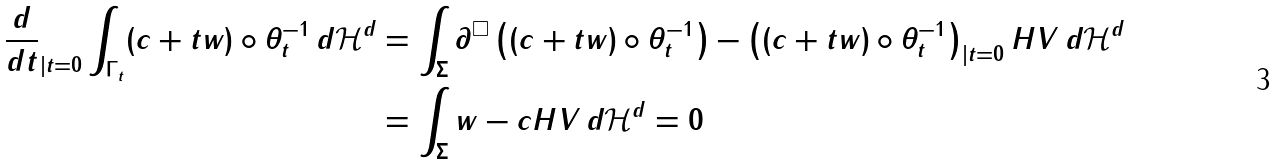<formula> <loc_0><loc_0><loc_500><loc_500>\frac { d } { d t } _ { | t = 0 } \int _ { \Gamma _ { t } } ( c + t w ) \circ \theta _ { t } ^ { - 1 } \, d \mathcal { H } ^ { d } & = \int _ { \Sigma } \partial ^ { \square } \left ( ( c + t w ) \circ \theta _ { t } ^ { - 1 } \right ) - \left ( ( c + t w ) \circ \theta _ { t } ^ { - 1 } \right ) _ { | t = 0 } H V \, d \mathcal { H } ^ { d } \\ & = \int _ { \Sigma } w - c H V \, d \mathcal { H } ^ { d } = 0</formula> 